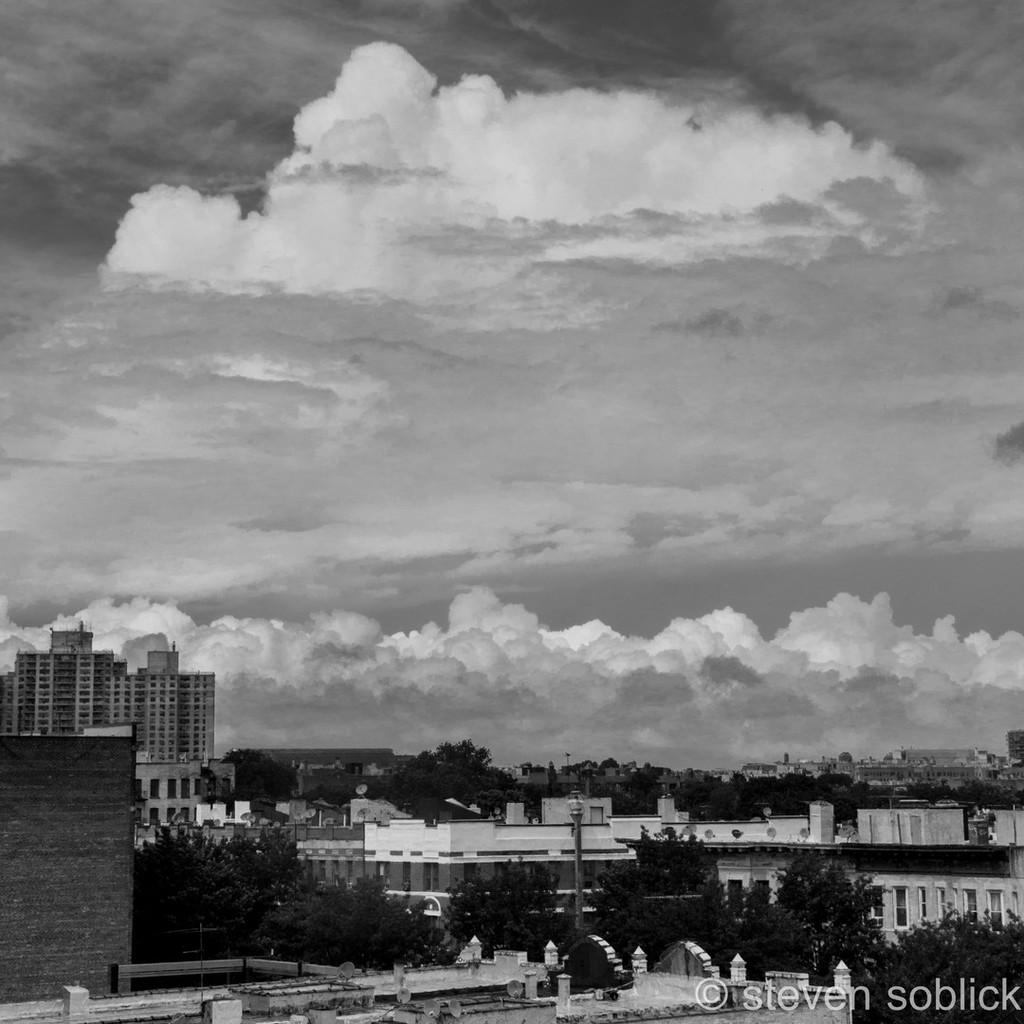What is the color scheme of the image? The image is black and white. What can be seen in the foreground of the image? There are buildings and trees in the foreground of the image, along with a pole. Can you describe the background of the image? There are clouds and the sky visible in the background of the image. How many bears can be seen in the crowd in the image? There are no bears or crowd present in the image. Is there an airplane visible in the sky in the image? There is no airplane visible in the sky in the image; only clouds and the sky are present. 